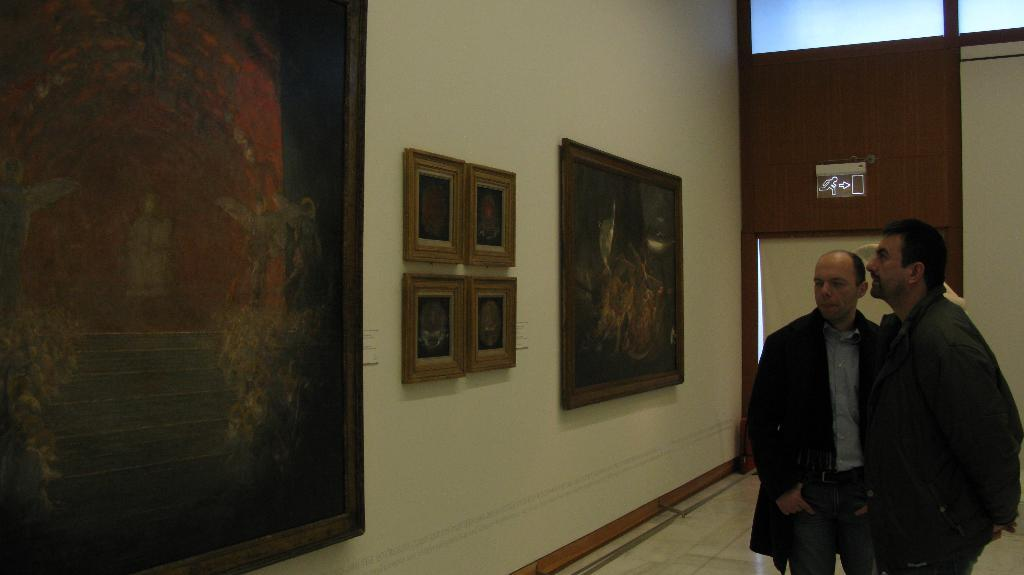What is hanging on the wall in the image? There are pictures on the wall in the image. What kind of object is present in the image that displays information or advertisements? There is a signboard in the image. Can you describe the people visible in the image? There are people visible in the image, but their specific actions or appearances are not mentioned in the provided facts. Are there any spies visible in the image? There is no mention of spies in the provided facts, so it cannot be determined if any are present in the image. Can you describe the hydrant located near the people in the image? There is no hydrant mentioned in the provided facts, so it cannot be determined if one is present in the image. 